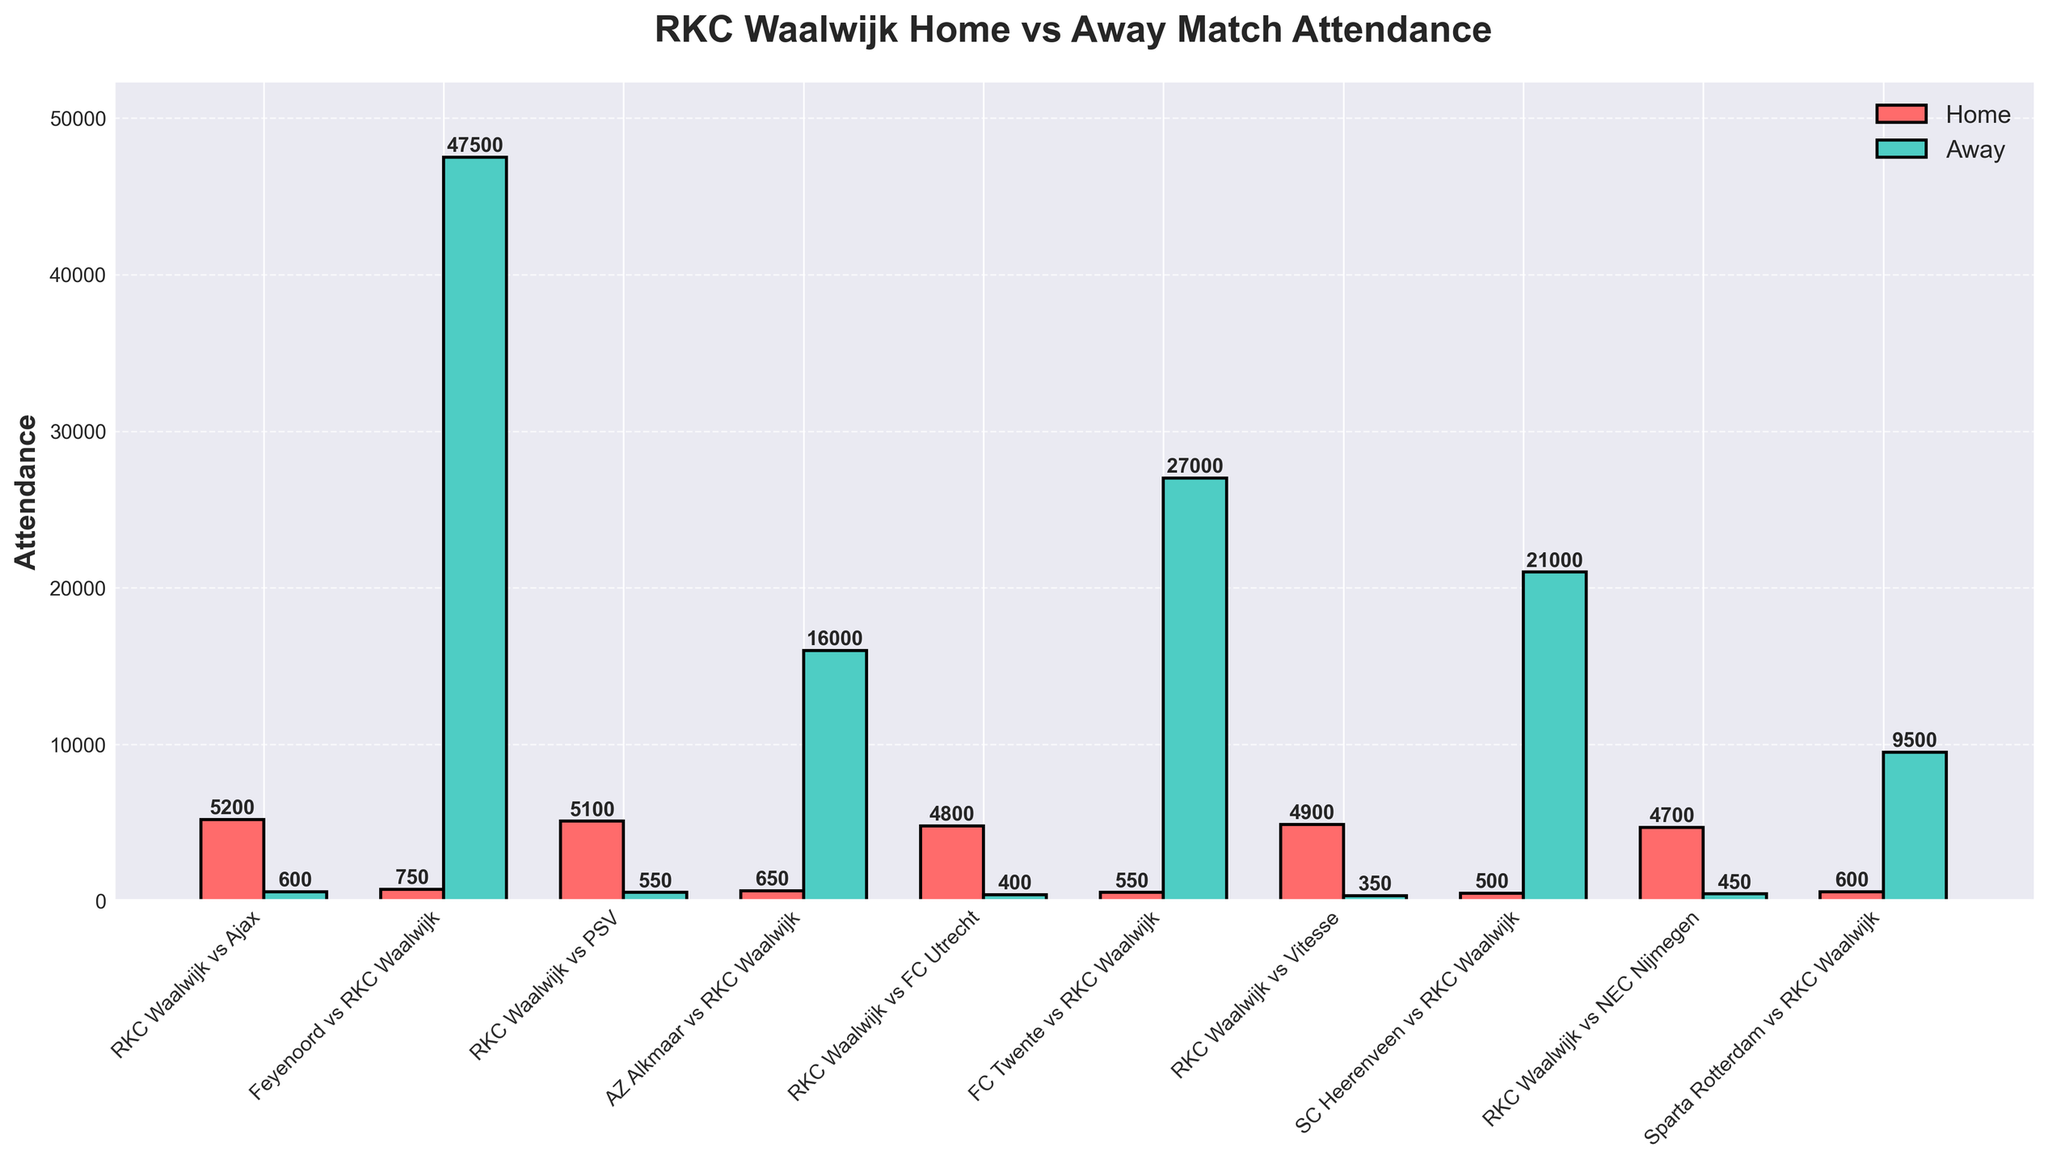Which match had the highest home attendance for RKC Waalwijk? By examining the height of the red bars, we can see that the tallest one represents the match RKC Waalwijk vs Ajax, with an attendance of 5200.
Answer: RKC Waalwijk vs Ajax Which match had the highest away attendance? By looking at the height of the green bars, the match with the highest away attendance is Feyenoord vs RKC Waalwijk, with an attendance of 47,500.
Answer: Feyenoord vs RKC Waalwijk What is the difference in attendance between RKC Waalwijk's home match vs Ajax and their away match vs Feyenoord? The home attendance vs Ajax is 5200 and the away attendance vs Feyenoord is 47,500. The difference is 47,500 - 5200 = 42,300.
Answer: 42,300 Which match had the smallest away attendance? By observing the shortest green bars, we see that the match RKC Waalwijk vs Vitesse had the smallest away attendance of 350.
Answer: RKC Waalwijk vs Vitesse What is the total home attendance for all RKC Waalwijk matches shown? We add up all the home attendances: 5200 + 5100 + 4800 + 4900 + 4700 = 24,700.
Answer: 24,700 Which match shows a visual difference where home attendance is significantly higher than away attendance? Comparing visual heights of the red and green bars, the match RKC Waalwijk vs PSV has a home attendance of 5100 and an away attendance of just 550, which shows a significant visual difference.
Answer: RKC Waalwijk vs PSV What is the average away attendance for RKC Waalwijk's matches? We sum all the away attendances and divide by the number of matches: (600 + 47,500 + 550 + 16,000 + 400 + 27,000 + 350 + 21,000 + 450 + 9500) / 10 = 12,235.
Answer: 12,235 How many matches had a home attendance greater than 5000? By checking the heights of the red bars, we see that RKC Waalwijk vs Ajax (5200) and RKC Waalwijk vs PSV (5100) both had home attendances greater than 5000. Therefore, the count is 2.
Answer: 2 If you sum the highest home attendance and the lowest away attendance, what is the result? The highest home attendance is 5200 (RKC Waalwijk vs Ajax) and the lowest away attendance is 350 (RKC Waalwijk vs Vitesse). Summing them gives 5200 + 350 = 5550.
Answer: 5550 